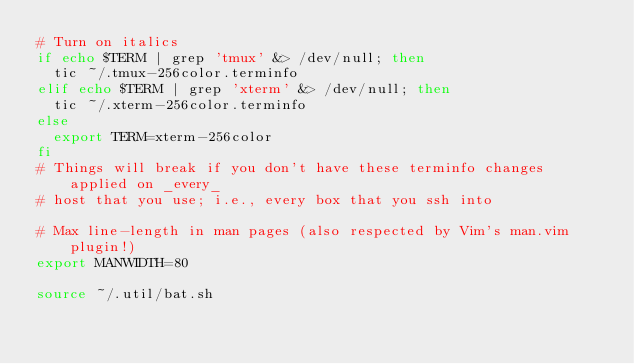<code> <loc_0><loc_0><loc_500><loc_500><_Bash_># Turn on italics
if echo $TERM | grep 'tmux' &> /dev/null; then
  tic ~/.tmux-256color.terminfo
elif echo $TERM | grep 'xterm' &> /dev/null; then
  tic ~/.xterm-256color.terminfo
else
  export TERM=xterm-256color
fi
# Things will break if you don't have these terminfo changes applied on _every_
# host that you use; i.e., every box that you ssh into

# Max line-length in man pages (also respected by Vim's man.vim plugin!)
export MANWIDTH=80

source ~/.util/bat.sh
</code> 